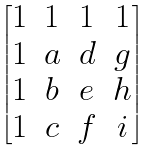<formula> <loc_0><loc_0><loc_500><loc_500>\begin{bmatrix} 1 & 1 & 1 & 1 \\ 1 & a & d & g \\ 1 & b & e & h \\ 1 & c & f & i \end{bmatrix}</formula> 